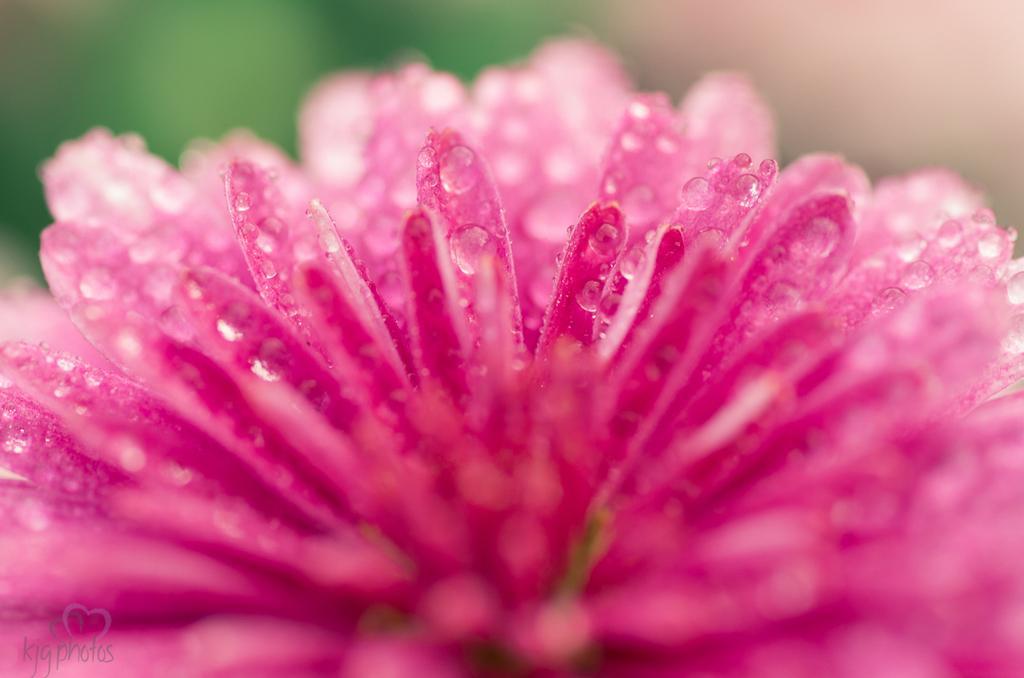Could you give a brief overview of what you see in this image? In the picture I can see a pink color flower and dew on it. The background of the image is blurred, which is in green color. Here we can see the watermark at the bottom left side of the image. 